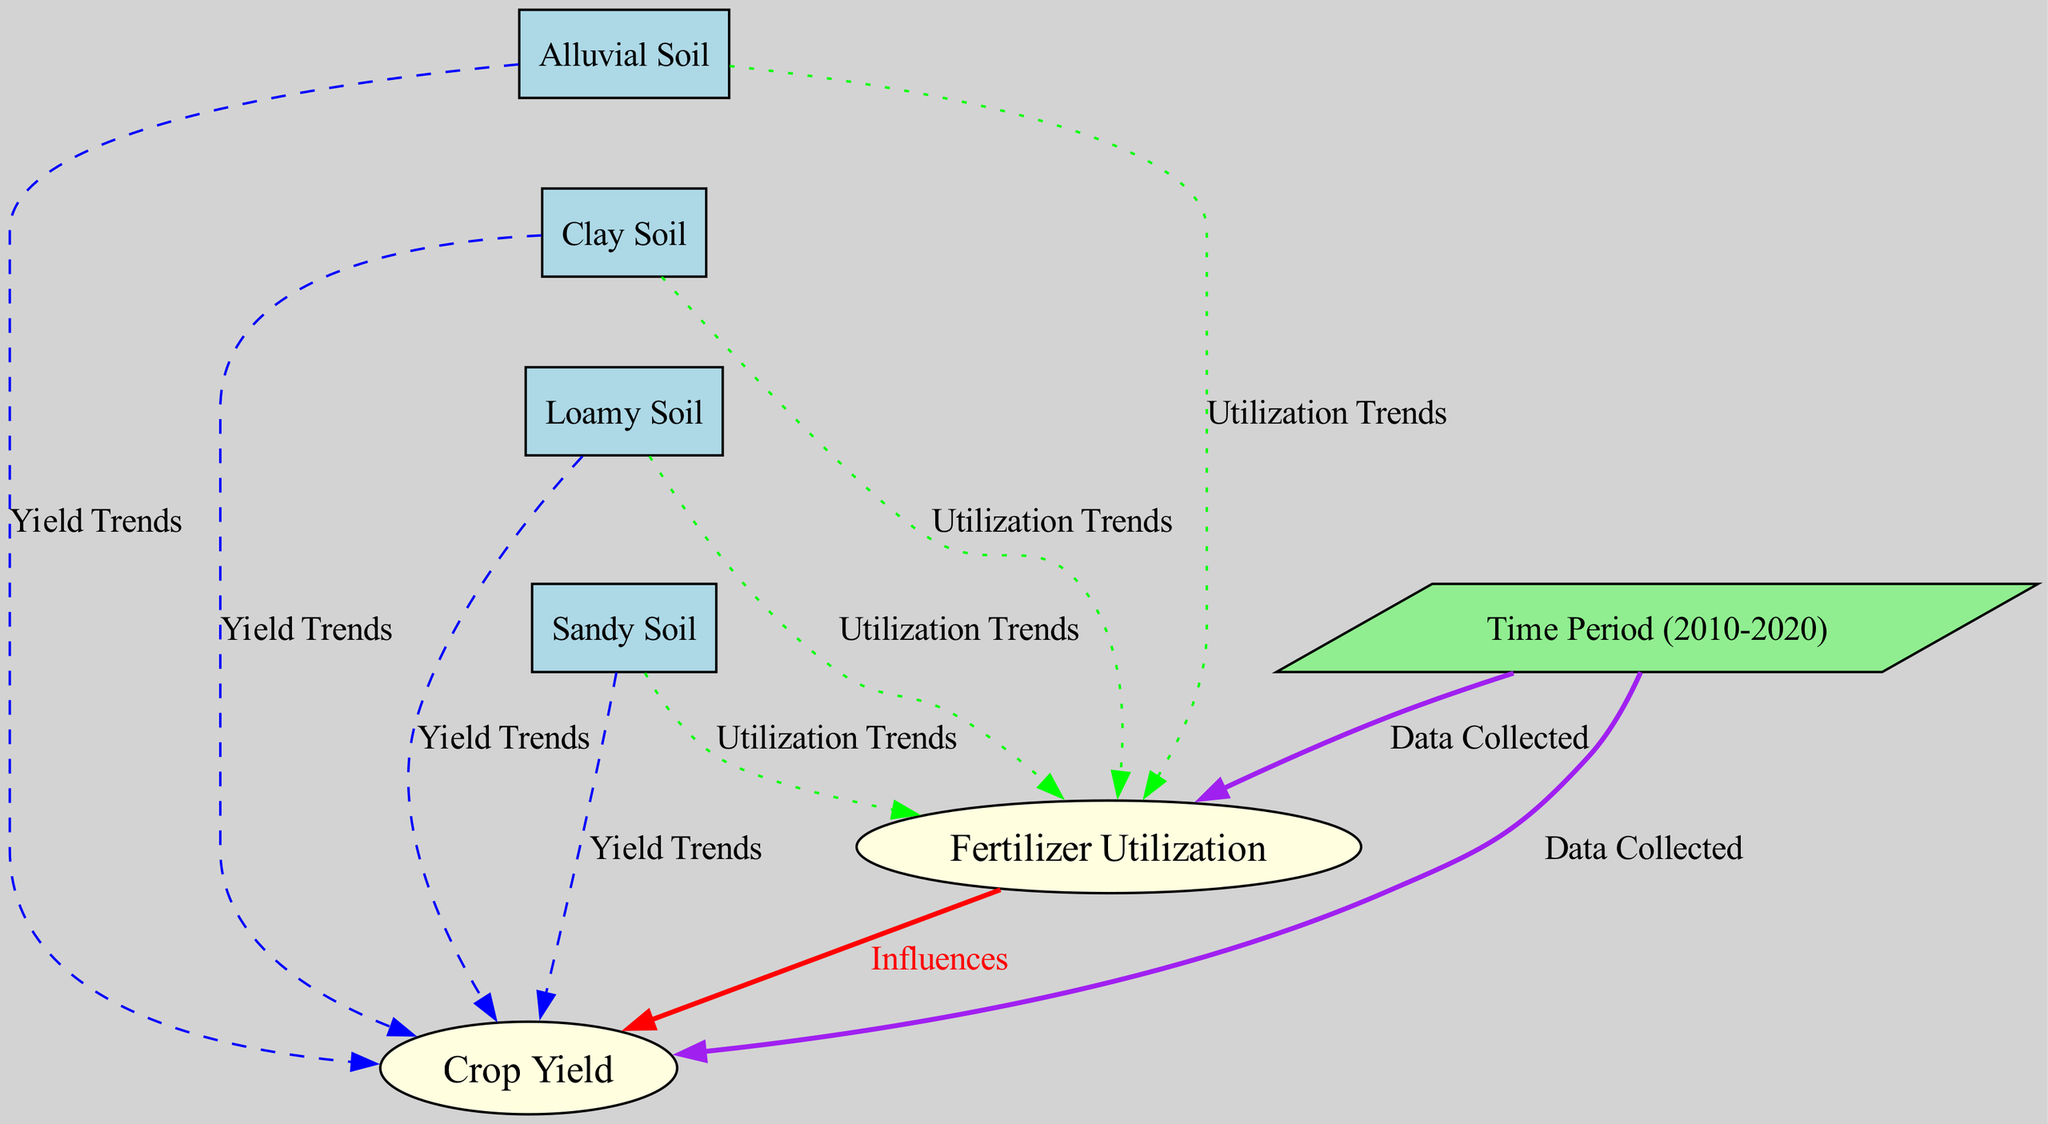What are the two main variables compared in the diagram? The diagram focuses on two main variables: crop yield and fertilizer utilization. These are prominently displayed as the main nodes in the diagram.
Answer: crop yield, fertilizer utilization How many soil types are represented in the diagram? There are four different soil types represented: alluvial soil, clay soil, loamy soil, and sandy soil. Each type is shown as a distinct node connected to the other variables.
Answer: four What type of relationship exists between fertilizer utilization and crop yield? The diagram indicates that fertilizer utilization influences crop yield. This is depicted by an edge labeled "Influences" pointing from fertilizer utilization to crop yield, using a red line to indicate the strength of the influence.
Answer: influences Which soil type has the greatest impact on yield trends? While the diagram does not quantify the impact, all soil types are shown to have yield trends, indicating that they all contribute to crop yield in different ways. Since no specific measurements are provided, we cannot definitively state which type has the greatest impact without additional data.
Answer: All soil types What color indicates the "Utilization Trends" relationship in the diagram? The "Utilization Trends" relationship is represented by edges styled with a green color and dotted lines connecting each soil type to fertilizer utilization, showing the trend relationships in a subtle yet distinct manner.
Answer: green When was the data collected, according to the diagram? The time period for which the data was collected is indicated in the diagram as 2010-2020, representing a decade of data spanning those years. This information connects both crop yield and fertilizer utilization.
Answer: 2010-2020 Which soil type relationship line is dashed in the diagram? The dashed relationship lines indicate the "Yield Trends" from each soil type to crop yield, emphasizing the historical data trends without suggesting direct influence like the solid lines do.
Answer: dashed What is the function of the invisible edges in the diagram? The invisible edges serve to improve the layout and organization of the diagram without representing any direct relationships. They help to arrange the soil types visually while keeping the focus on the main relationships shown with visible edges.
Answer: layout improvement 